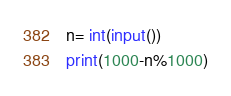Convert code to text. <code><loc_0><loc_0><loc_500><loc_500><_Python_>n= int(input())
print(1000-n%1000)</code> 